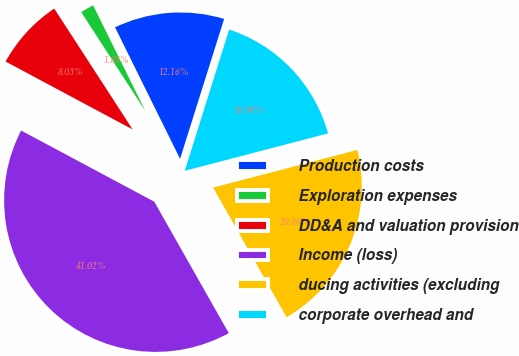Convert chart. <chart><loc_0><loc_0><loc_500><loc_500><pie_chart><fcel>Production costs<fcel>Exploration expenses<fcel>DD&A and valuation provision<fcel>Income (loss)<fcel>ducing activities (excluding<fcel>corporate overhead and<nl><fcel>12.16%<fcel>1.85%<fcel>8.03%<fcel>41.02%<fcel>20.86%<fcel>16.08%<nl></chart> 